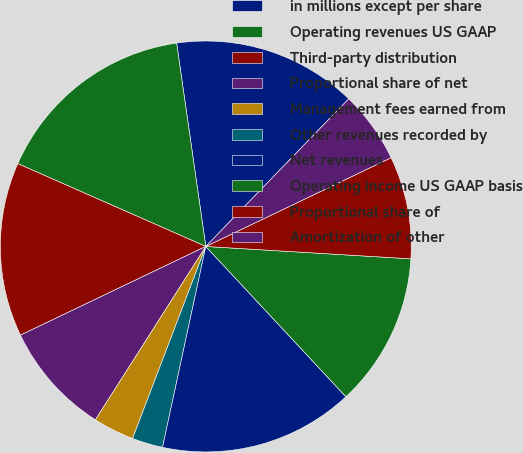<chart> <loc_0><loc_0><loc_500><loc_500><pie_chart><fcel>in millions except per share<fcel>Operating revenues US GAAP<fcel>Third-party distribution<fcel>Proportional share of net<fcel>Management fees earned from<fcel>Other revenues recorded by<fcel>Net revenues<fcel>Operating income US GAAP basis<fcel>Proportional share of<fcel>Amortization of other<nl><fcel>14.51%<fcel>16.13%<fcel>13.71%<fcel>8.87%<fcel>3.23%<fcel>2.42%<fcel>15.32%<fcel>12.1%<fcel>8.07%<fcel>5.65%<nl></chart> 